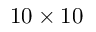<formula> <loc_0><loc_0><loc_500><loc_500>1 0 \times 1 0</formula> 